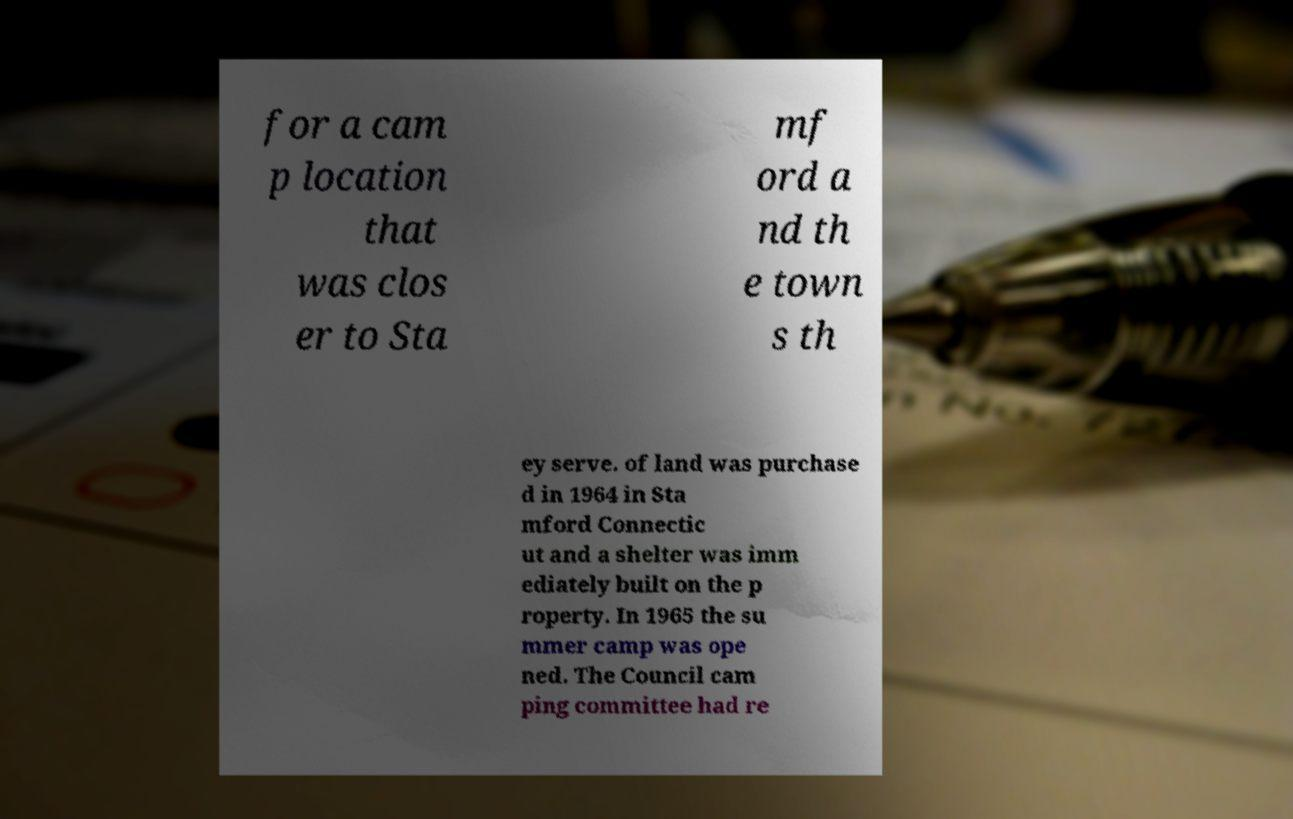Please identify and transcribe the text found in this image. for a cam p location that was clos er to Sta mf ord a nd th e town s th ey serve. of land was purchase d in 1964 in Sta mford Connectic ut and a shelter was imm ediately built on the p roperty. In 1965 the su mmer camp was ope ned. The Council cam ping committee had re 